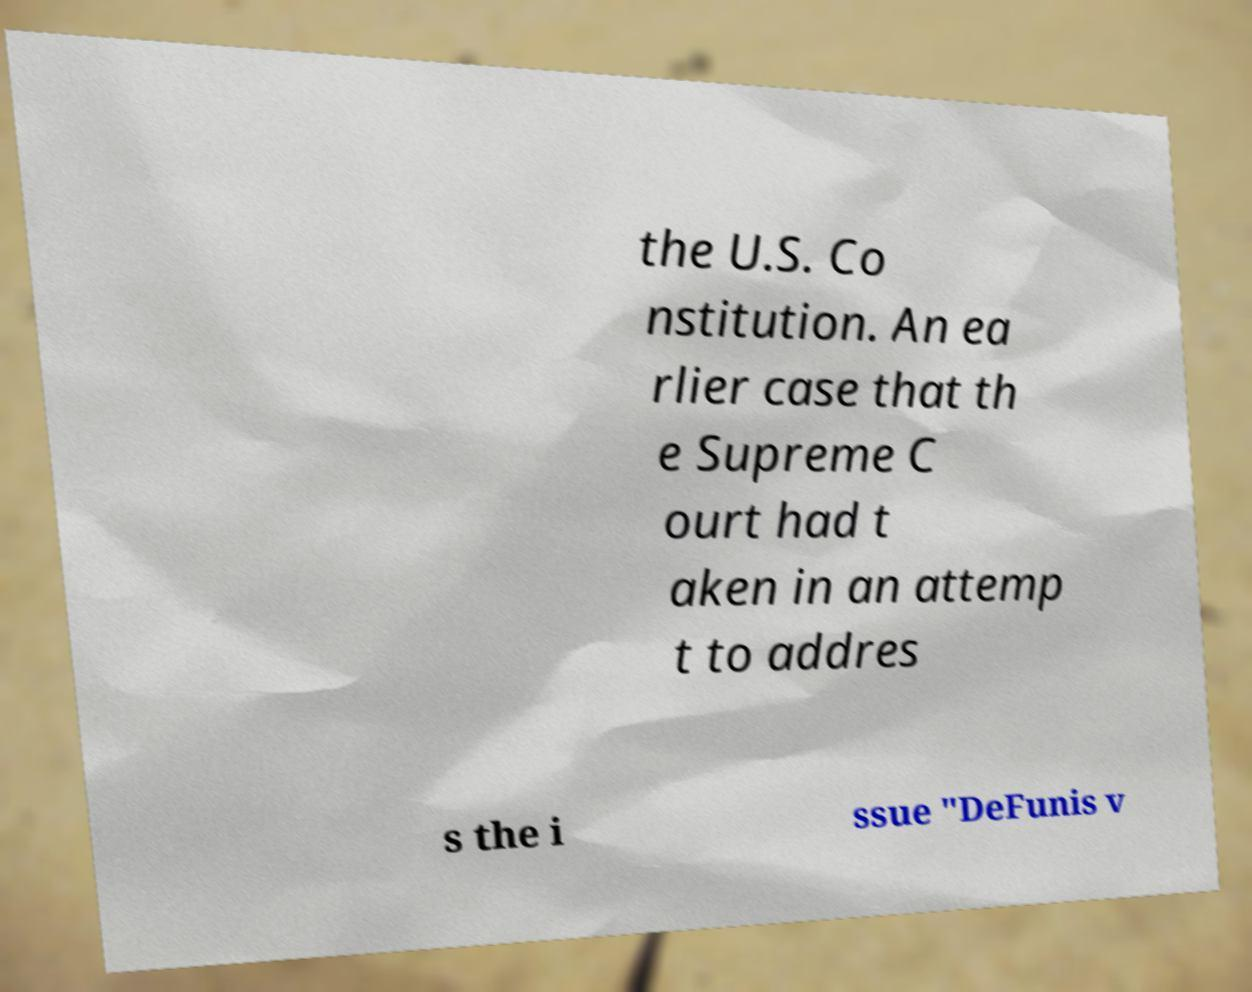Please read and relay the text visible in this image. What does it say? the U.S. Co nstitution. An ea rlier case that th e Supreme C ourt had t aken in an attemp t to addres s the i ssue "DeFunis v 